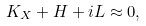<formula> <loc_0><loc_0><loc_500><loc_500>K _ { X } + H + i L \approx 0 ,</formula> 